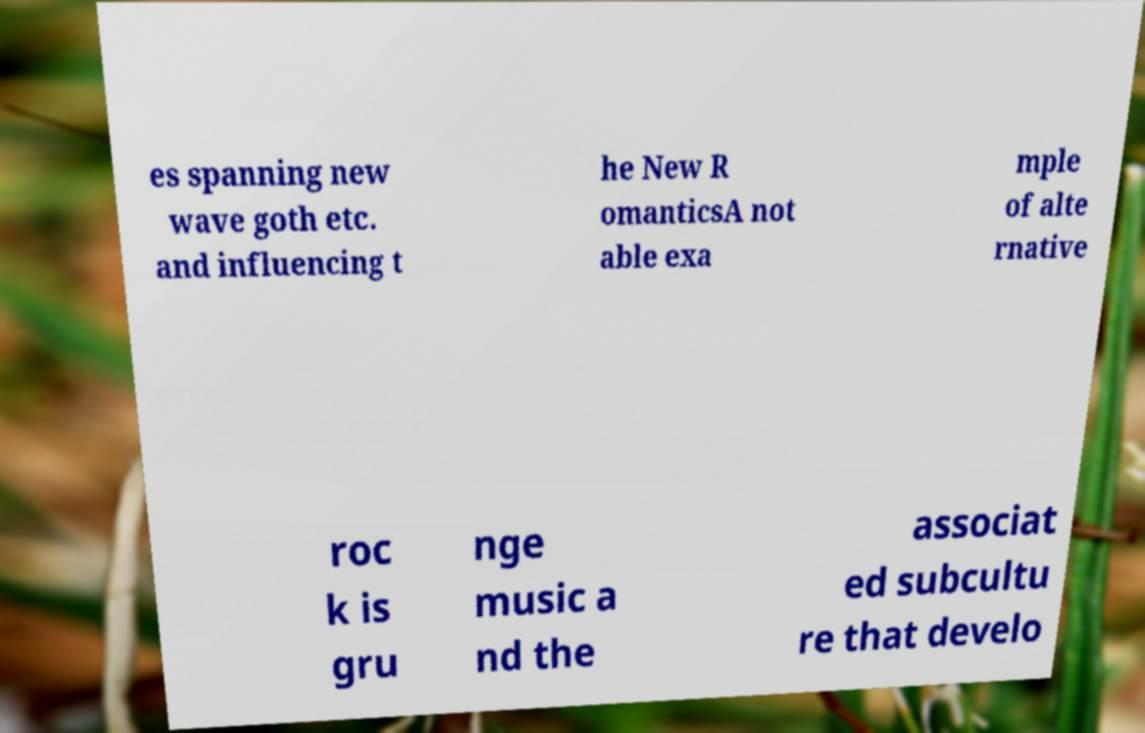Can you accurately transcribe the text from the provided image for me? es spanning new wave goth etc. and influencing t he New R omanticsA not able exa mple of alte rnative roc k is gru nge music a nd the associat ed subcultu re that develo 